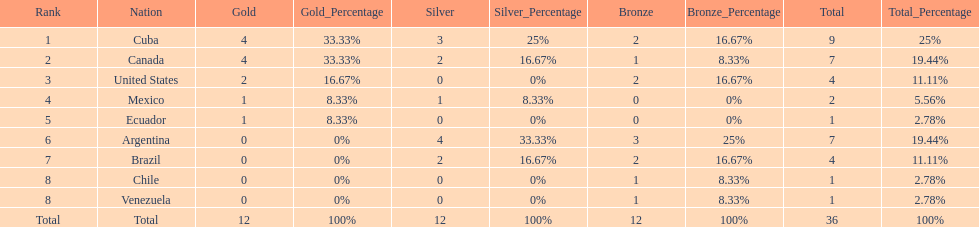Which country won the largest haul of bronze medals? Argentina. 